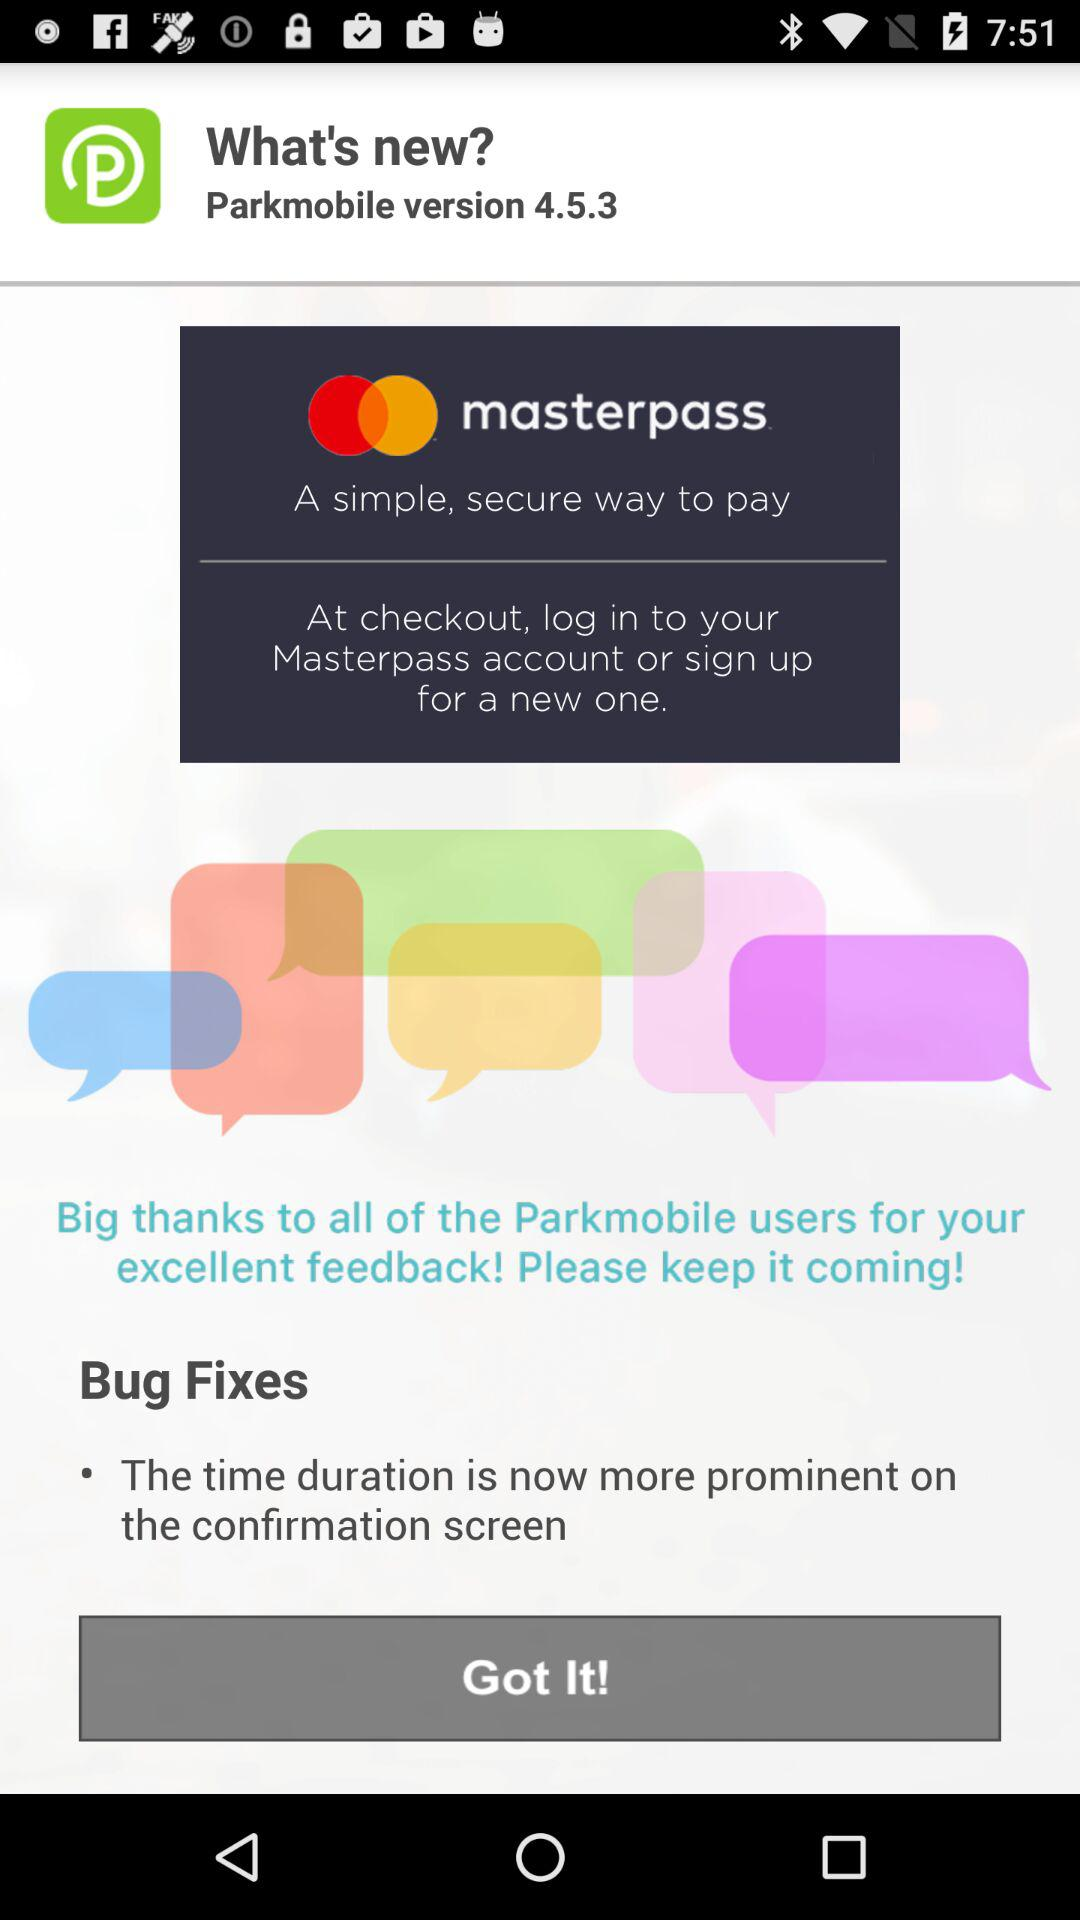What is the version? The version is 4.5.3. 